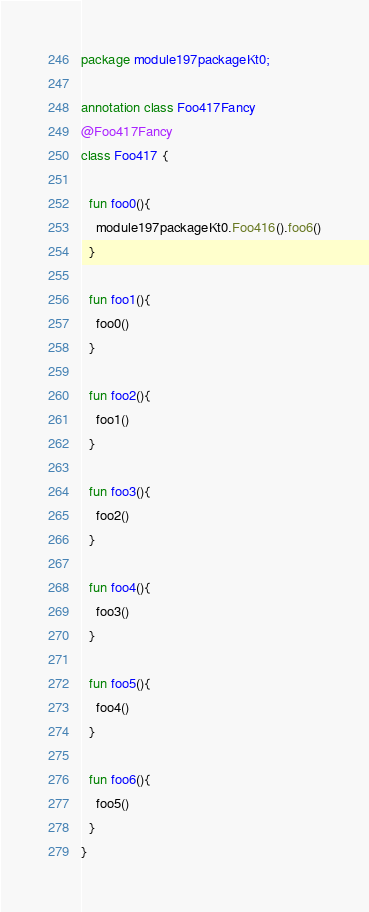<code> <loc_0><loc_0><loc_500><loc_500><_Kotlin_>package module197packageKt0;

annotation class Foo417Fancy
@Foo417Fancy
class Foo417 {

  fun foo0(){
    module197packageKt0.Foo416().foo6()
  }

  fun foo1(){
    foo0()
  }

  fun foo2(){
    foo1()
  }

  fun foo3(){
    foo2()
  }

  fun foo4(){
    foo3()
  }

  fun foo5(){
    foo4()
  }

  fun foo6(){
    foo5()
  }
}</code> 